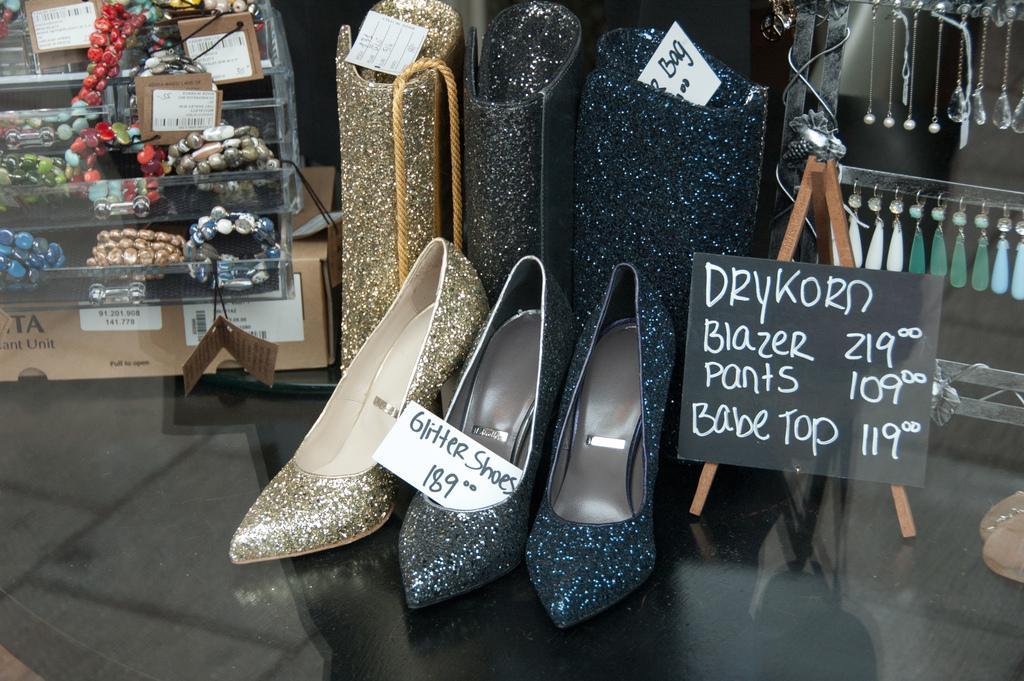In one or two sentences, can you explain what this image depicts? In this image I can see in the middle there are shoes and there is a price card. On the right side there is a black color board. 